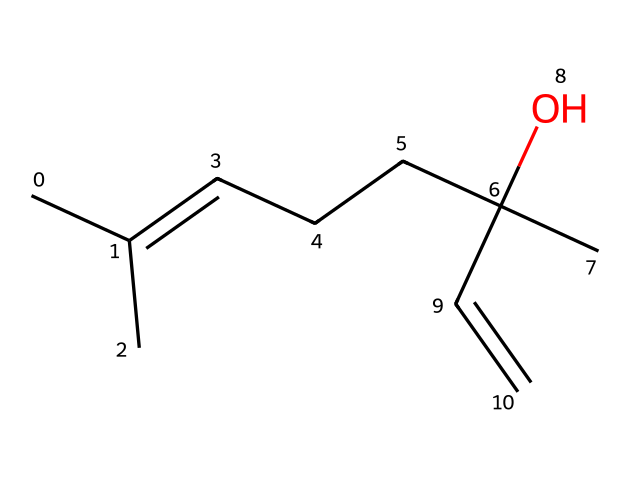What is the molecular formula of linalool? To derive the molecular formula, count the number of carbon (C), hydrogen (H), and oxygen (O) atoms in the SMILES representation. The structure shows 10 carbon atoms, 18 hydrogen atoms, and 1 oxygen atom. Thus, the molecular formula is C10H18O.
Answer: C10H18O How many chiral centers are present in linalool? A chiral center in a molecule is typically a carbon atom bonded to four different substituents. In the given structure, there is one carbon atom (the one connected to the hydroxyl group and double bond) that meets this criterion, indicating one chiral center.
Answer: 1 What type of hydroxyl group is present in linalool? A hydroxyl group (-OH) can be classified based on its attachment in the molecule. In linalool, it is attached to a tertiary carbon atom, which significantly affects the compound's properties. This attachment contributes to its reactivity and solubility.
Answer: tertiary What characteristic feature makes linalool a chiral compound? The presence of a carbon atom bonded to four distinct groups is the defining characteristic of chirality in a compound. In linalool, this carbon forms a unique 3D arrangement, distinguishing it from its mirror image, which is a hallmark of chiral species.
Answer: asymmetric carbon What bond type connects the carbon atoms in linalool? The structure includes both single and double bonds between the carbon atoms. The presence of a double bond indicates that two of the carbon atoms are connected by a pi bond, while the rest are connected by sigma bonds typical for aliphatic hydrocarbons like linalool.
Answer: single and double bonds Why is the structure of linalool significant for sustainable urban landscaping? The molecular structure of linalool contributes to its characteristic scent and potential therapeutic properties. These features can enhance the sensory experience in urban landscapes, making it a popular choice for planting, as it promotes a more inviting environment.
Answer: aromatic qualities 